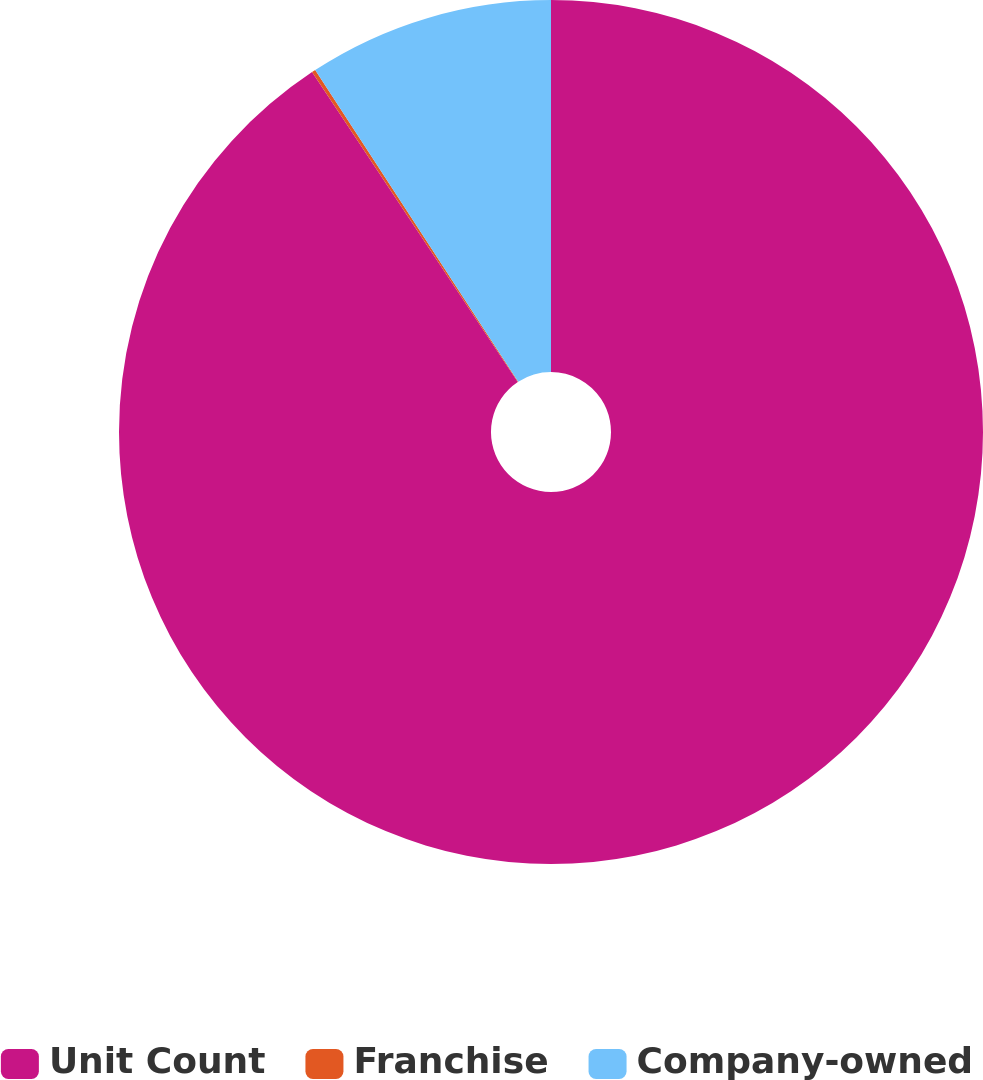Convert chart. <chart><loc_0><loc_0><loc_500><loc_500><pie_chart><fcel>Unit Count<fcel>Franchise<fcel>Company-owned<nl><fcel>90.68%<fcel>0.14%<fcel>9.19%<nl></chart> 